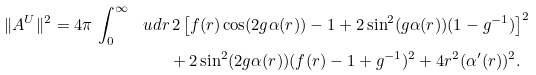<formula> <loc_0><loc_0><loc_500><loc_500>\| A ^ { U } \| ^ { 2 } = 4 \pi \, \int _ { 0 } ^ { \infty } \, \ u d r & \, 2 \left [ f ( r ) \cos ( 2 g \alpha ( r ) ) - 1 + 2 \sin ^ { 2 } ( g \alpha ( r ) ) ( 1 - g ^ { - 1 } ) \right ] ^ { 2 } \\ & + 2 \sin ^ { 2 } ( 2 g \alpha ( r ) ) ( f ( r ) - 1 + g ^ { - 1 } ) ^ { 2 } + 4 r ^ { 2 } ( \alpha ^ { \prime } ( r ) ) ^ { 2 } .</formula> 